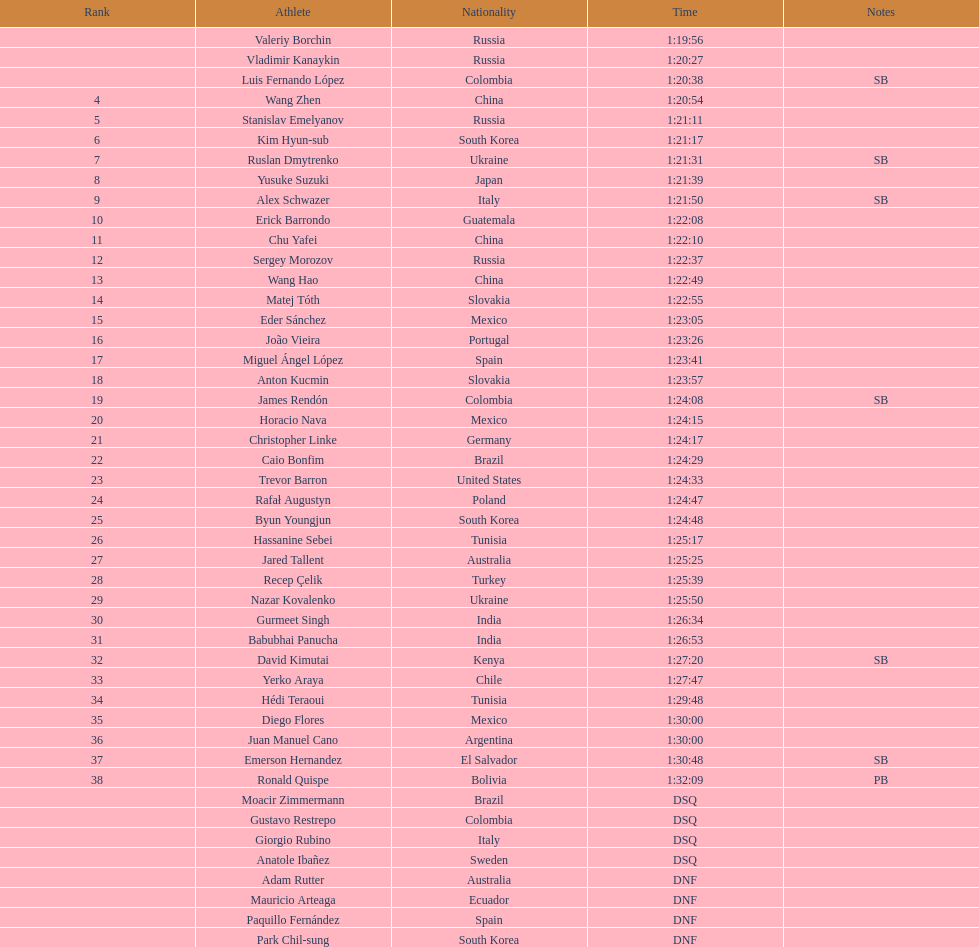Which player is the exclusive american to be positioned in the 20km? Trevor Barron. 